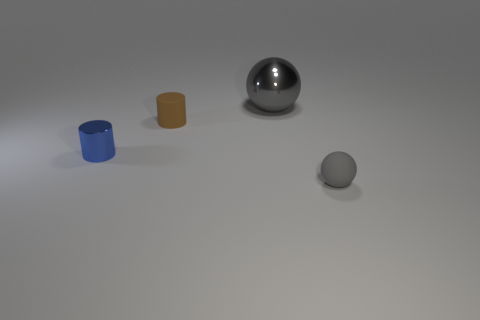Is there any other thing that has the same size as the gray metal ball?
Make the answer very short. No. How many cyan cubes have the same material as the tiny brown cylinder?
Give a very brief answer. 0. What number of things are either cylinders that are in front of the matte cylinder or tiny red shiny cubes?
Give a very brief answer. 1. How big is the blue metallic thing?
Provide a short and direct response. Small. What is the material of the gray sphere behind the ball that is in front of the tiny brown matte cylinder?
Your answer should be very brief. Metal. Do the metal object in front of the gray metallic object and the big gray metal thing have the same size?
Your answer should be compact. No. Are there any objects of the same color as the metallic ball?
Your answer should be compact. Yes. What number of objects are either metallic objects that are right of the blue shiny object or rubber things left of the gray metal ball?
Keep it short and to the point. 2. Does the rubber sphere have the same color as the small metallic object?
Your answer should be compact. No. What material is the other tiny sphere that is the same color as the metallic ball?
Provide a succinct answer. Rubber. 